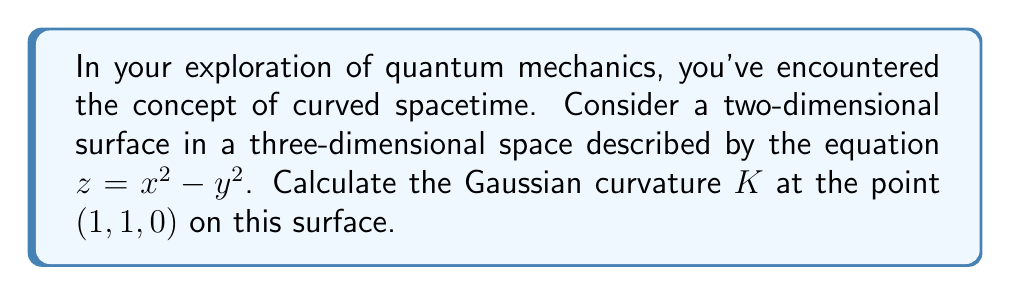Solve this math problem. To calculate the Gaussian curvature of a surface at a given point, we'll follow these steps:

1) First, we need to find the first and second fundamental forms of the surface. The surface is given by $z = x^2 - y^2$.

2) Let's parameterize the surface using $u = x$ and $v = y$:
   $r(u,v) = (u, v, u^2 - v^2)$

3) Calculate the partial derivatives:
   $r_u = (1, 0, 2u)$
   $r_v = (0, 1, -2v)$
   $r_{uu} = (0, 0, 2)$
   $r_{vv} = (0, 0, -2)$
   $r_{uv} = (0, 0, 0)$

4) Calculate the coefficients of the first fundamental form:
   $E = r_u \cdot r_u = 1 + 4u^2$
   $F = r_u \cdot r_v = 0$
   $G = r_v \cdot r_v = 1 + 4v^2$

5) Calculate the unit normal vector:
   $N = \frac{r_u \times r_v}{|r_u \times r_v|} = \frac{(-2u, 2v, 1)}{\sqrt{1 + 4u^2 + 4v^2}}$

6) Calculate the coefficients of the second fundamental form:
   $e = r_{uu} \cdot N = \frac{2}{\sqrt{1 + 4u^2 + 4v^2}}$
   $f = r_{uv} \cdot N = 0$
   $g = r_{vv} \cdot N = \frac{-2}{\sqrt{1 + 4u^2 + 4v^2}}$

7) The Gaussian curvature is given by:
   $K = \frac{eg - f^2}{EG - F^2}$

8) Substitute the values at the point $(1, 1, 0)$:
   $K = \frac{(\frac{2}{\sqrt{9}})(\frac{-2}{\sqrt{9}}) - 0^2}{(5)(5) - 0^2} = \frac{-4/9}{25} = -\frac{4}{225}$

Therefore, the Gaussian curvature at the point $(1, 1, 0)$ is $-\frac{4}{225}$.
Answer: $-\frac{4}{225}$ 